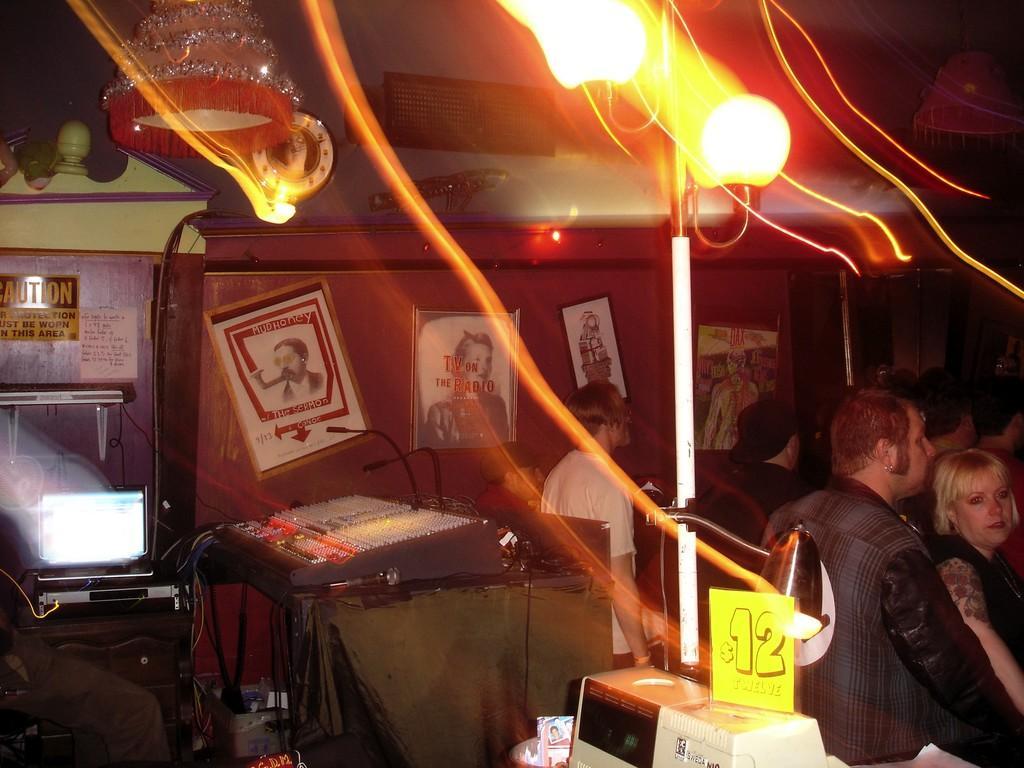In one or two sentences, can you explain what this image depicts? In the image there are few people standing. At the top of the image there are lights. At the bottom of the image there is an object with a price tag. Behind that there is a table with machine and mics. And on the left side of the image there is a monitor and some other things on the table. In the background there is a wall with frames. And also there are some other things in the background. 